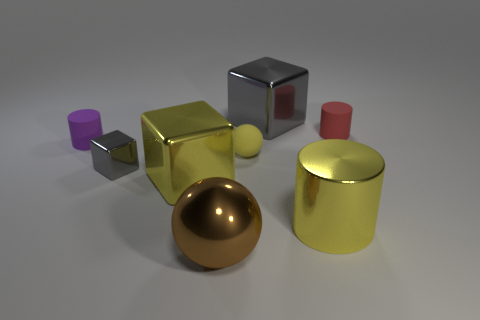Is there any other thing of the same color as the large metallic ball?
Your answer should be very brief. No. How many other things are there of the same material as the brown thing?
Provide a succinct answer. 4. What size is the brown object?
Provide a short and direct response. Large. Is there a tiny yellow object of the same shape as the large brown thing?
Make the answer very short. Yes. How many things are brown metallic objects or small things to the right of the tiny gray object?
Offer a terse response. 3. There is a matte cylinder that is on the right side of the big gray shiny cube; what color is it?
Provide a short and direct response. Red. There is a rubber cylinder that is on the right side of the large cylinder; is it the same size as the gray thing that is in front of the red cylinder?
Provide a succinct answer. Yes. Is there a purple object that has the same size as the yellow matte sphere?
Make the answer very short. Yes. How many small things are to the right of the yellow object that is on the right side of the yellow rubber ball?
Ensure brevity in your answer.  1. What material is the big sphere?
Provide a succinct answer. Metal. 